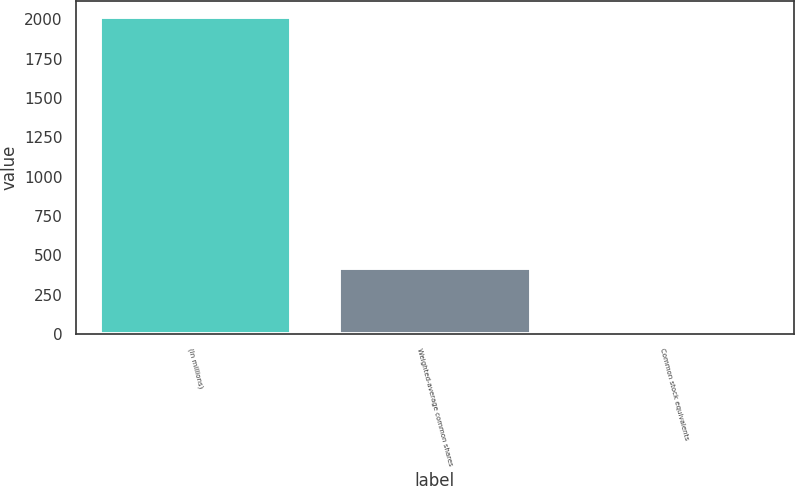<chart> <loc_0><loc_0><loc_500><loc_500><bar_chart><fcel>(In millions)<fcel>Weighted-average common shares<fcel>Common stock equivalents<nl><fcel>2016<fcel>421.54<fcel>3.6<nl></chart> 